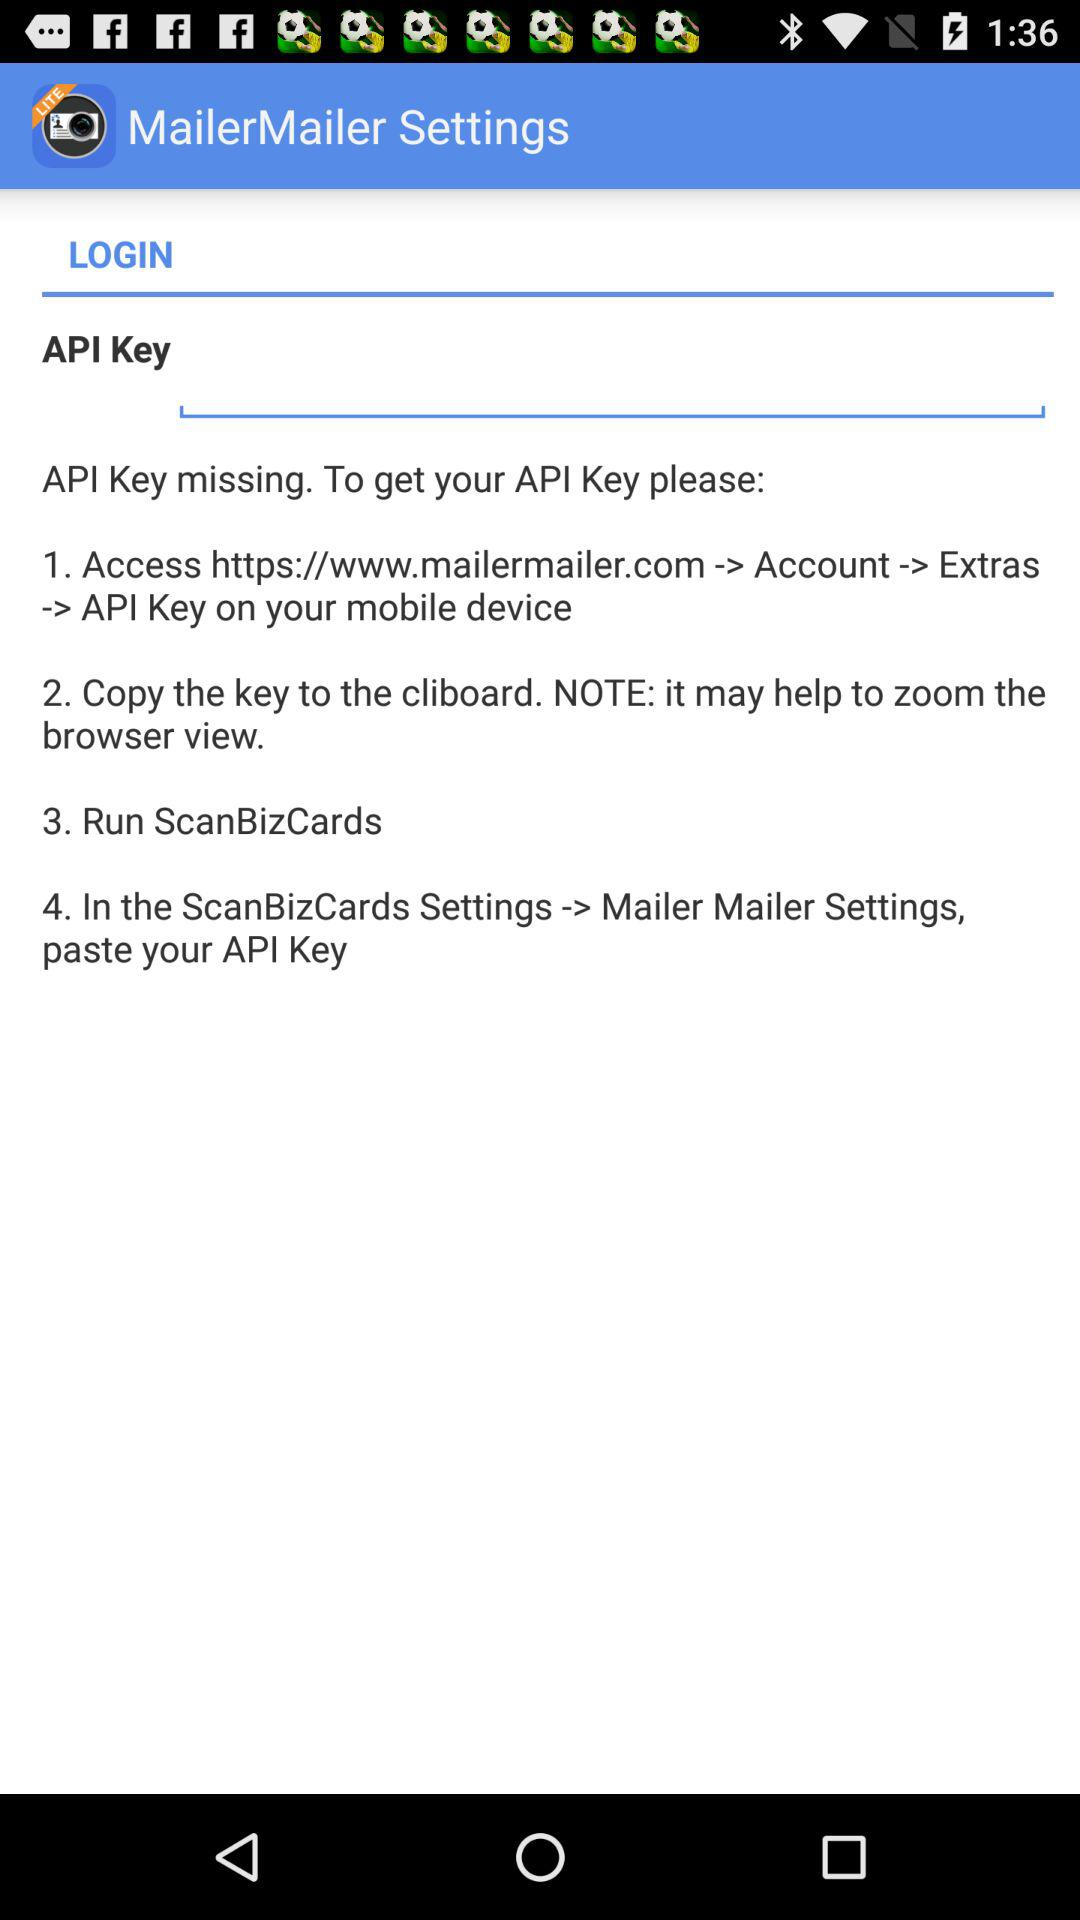How many steps are there in the instructions to get an API key?
Answer the question using a single word or phrase. 4 